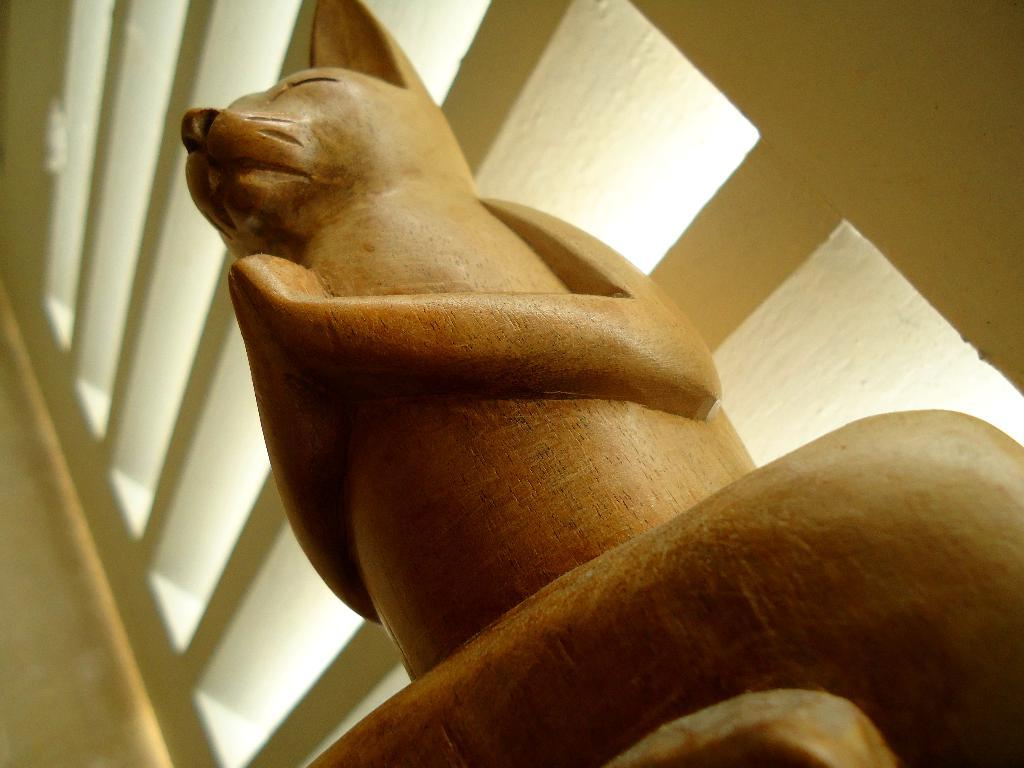What is the main subject of the image? There is an animal statue in the image. Can you describe the background of the image? There is a wall visible behind the statue. What type of question is the animal statue asking in the image? There is no indication in the image that the animal statue is asking a question. 